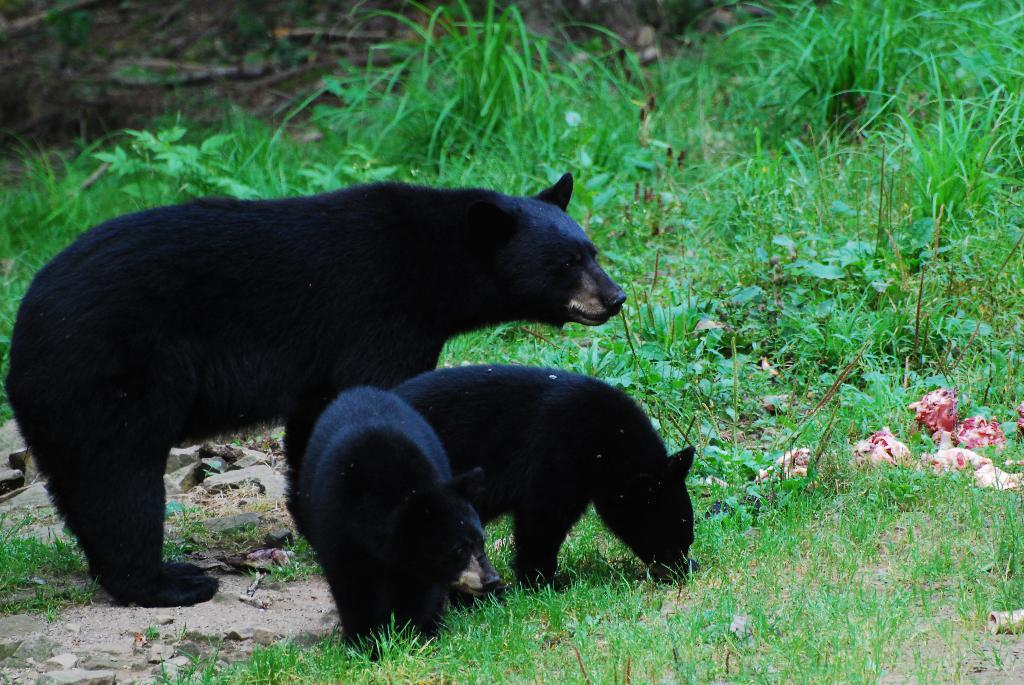What types of living organisms can be seen in the image? Animals and plants are visible in the image. What type of vegetation is present in the image? Grass is present in the image. What else can be found on the ground in the image? There are other objects on the ground in the image. What type of insurance policy is being discussed by the animals in the image? There is no indication in the image that the animals are discussing any insurance policies. 